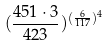Convert formula to latex. <formula><loc_0><loc_0><loc_500><loc_500>( \frac { 4 5 1 \cdot 3 } { 4 2 3 } ) ^ { ( \frac { 6 } { 1 1 7 } ) ^ { 4 } }</formula> 